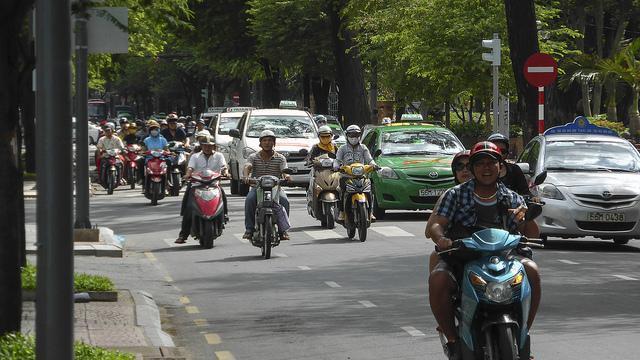How many directions does traffic flow in these pictured lanes?
Make your selection and explain in format: 'Answer: answer
Rationale: rationale.'
Options: Two, none, three, one. Answer: one.
Rationale: The traffic is all going the same way. 